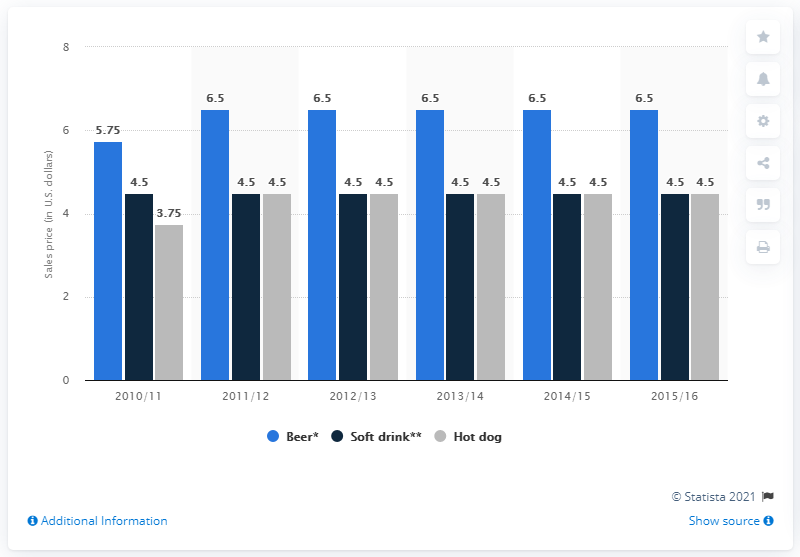Draw attention to some important aspects in this diagram. In the year 2010/11, the sales price of hot dogs was at its lowest point. The sales price of beer and soft drinks in the year 2015/16 differed. 